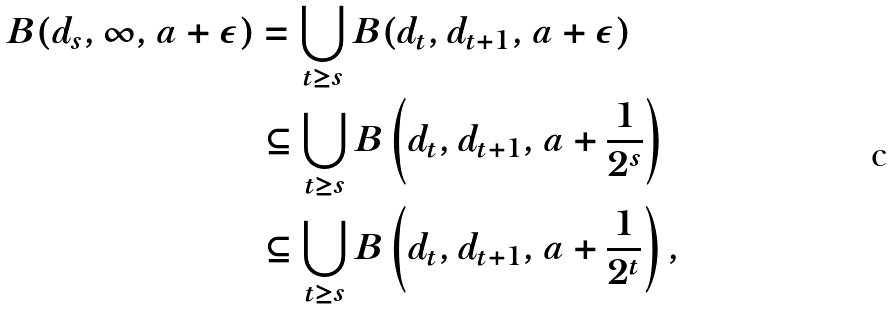<formula> <loc_0><loc_0><loc_500><loc_500>B ( d _ { s } , \infty , a + \epsilon ) & = \bigcup _ { t \geq s } B ( d _ { t } , d _ { t + 1 } , a + \epsilon ) \\ & \subseteq \bigcup _ { t \geq s } B \left ( d _ { t } , d _ { t + 1 } , a + \frac { 1 } { 2 ^ { s } } \right ) \\ & \subseteq \bigcup _ { t \geq s } B \left ( d _ { t } , d _ { t + 1 } , a + \frac { 1 } { 2 ^ { t } } \right ) ,</formula> 